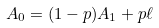Convert formula to latex. <formula><loc_0><loc_0><loc_500><loc_500>A _ { 0 } = ( 1 - p ) A _ { 1 } + p \ell</formula> 